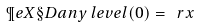Convert formula to latex. <formula><loc_0><loc_0><loc_500><loc_500>\P e { X } { \S D { a n y \, l e v e l } { ( 0 ) } } = \ r x</formula> 